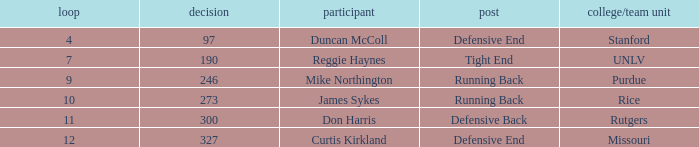What is the highest round number for the player who came from team Missouri? 12.0. 